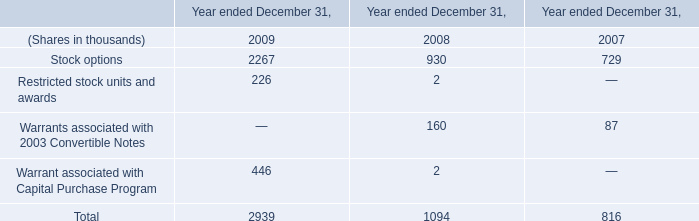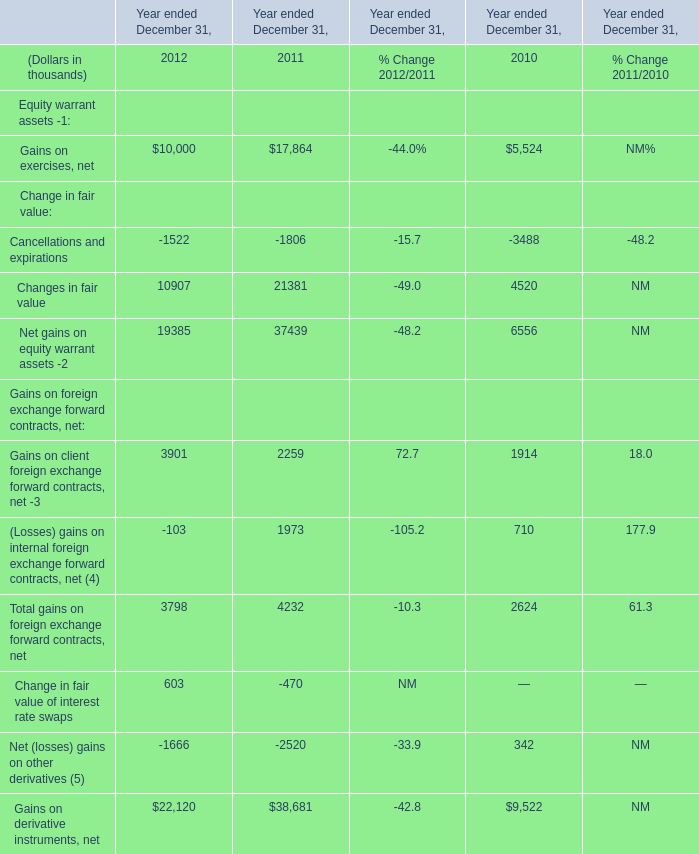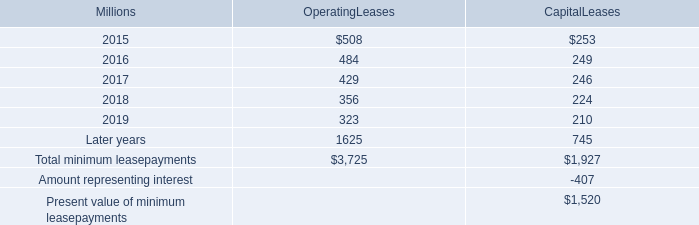In the year with the most Changes in fair value, what is the growth rate of Total gains on foreign exchange forward contracts, net? (in %) 
Computations: ((4232 - 2624) / 2624)
Answer: 0.6128. 